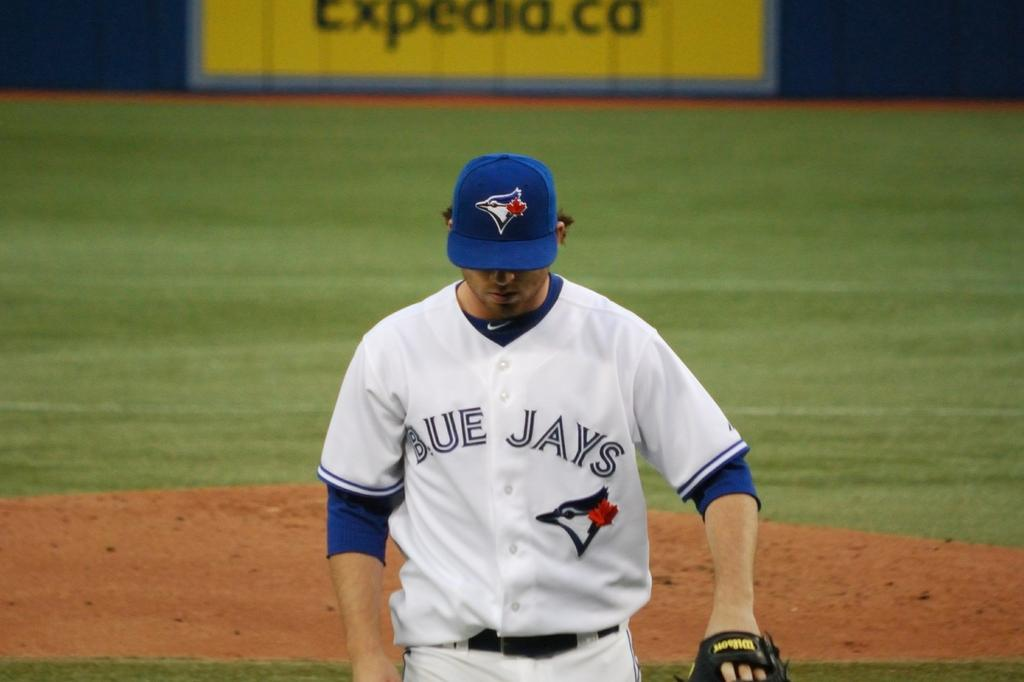<image>
Share a concise interpretation of the image provided. The baseball player walking toward home plate plays for the Blue Jays. 